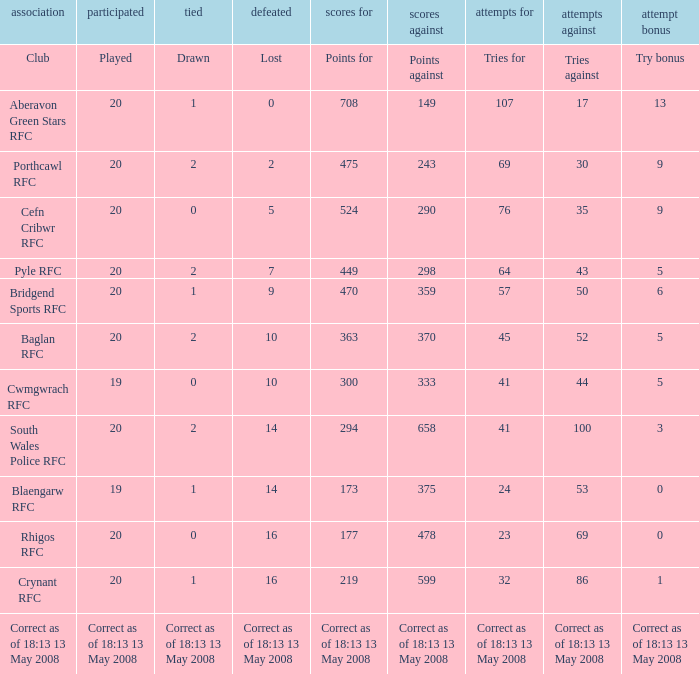What club has a played number of 19, and the lost of 14? Blaengarw RFC. 